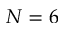<formula> <loc_0><loc_0><loc_500><loc_500>N = 6</formula> 